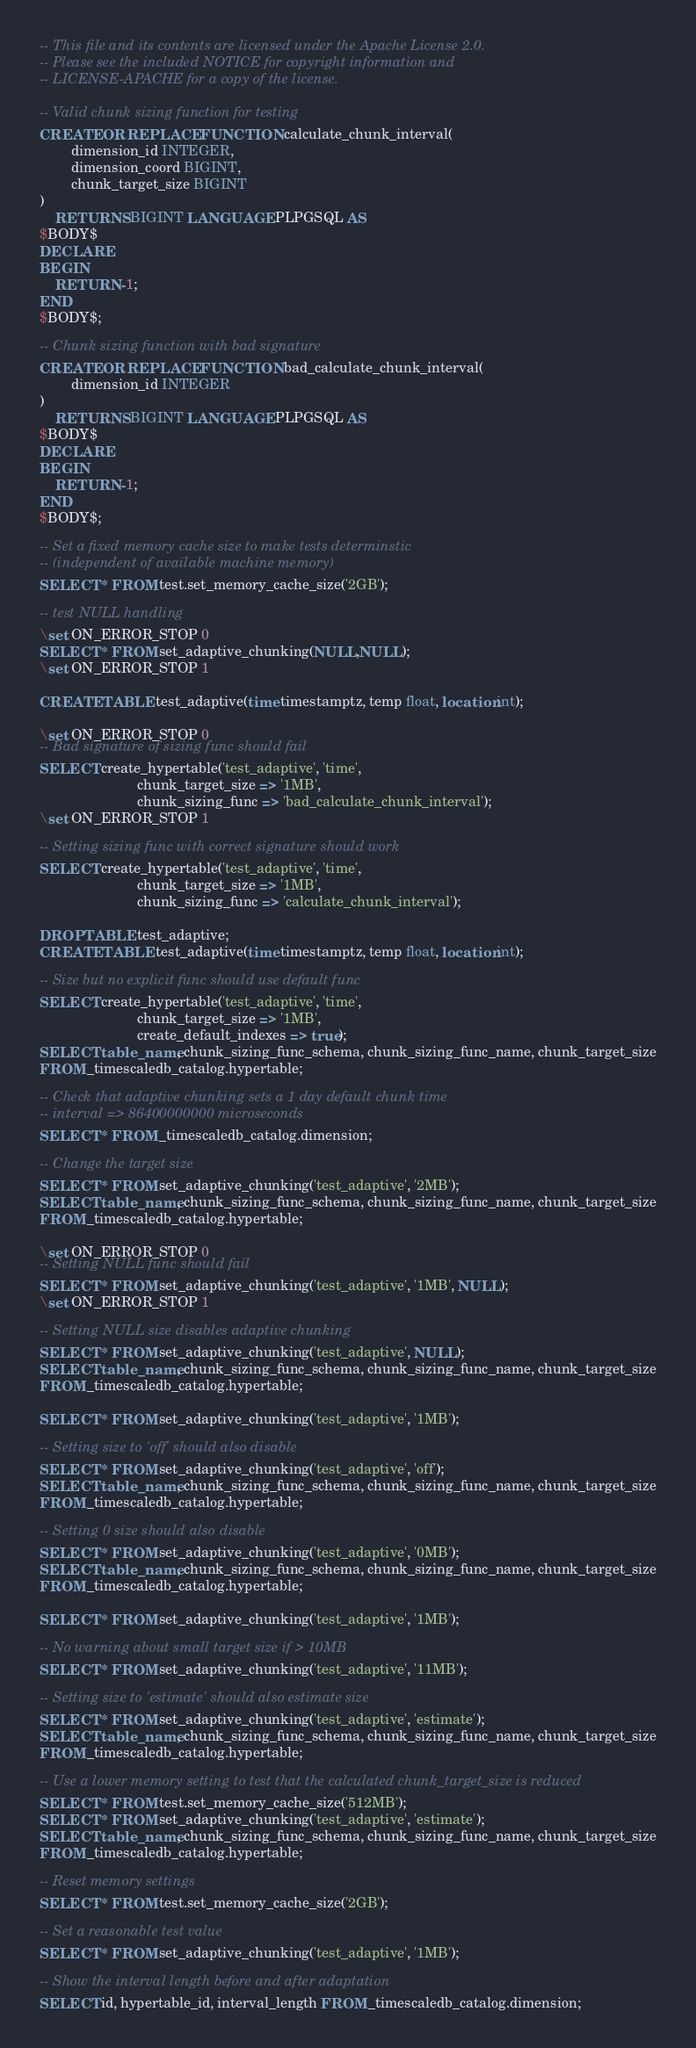<code> <loc_0><loc_0><loc_500><loc_500><_SQL_>-- This file and its contents are licensed under the Apache License 2.0.
-- Please see the included NOTICE for copyright information and
-- LICENSE-APACHE for a copy of the license.

-- Valid chunk sizing function for testing
CREATE OR REPLACE FUNCTION calculate_chunk_interval(
        dimension_id INTEGER,
        dimension_coord BIGINT,
        chunk_target_size BIGINT
)
    RETURNS BIGINT LANGUAGE PLPGSQL AS
$BODY$
DECLARE
BEGIN
    RETURN -1;
END
$BODY$;

-- Chunk sizing function with bad signature
CREATE OR REPLACE FUNCTION bad_calculate_chunk_interval(
        dimension_id INTEGER
)
    RETURNS BIGINT LANGUAGE PLPGSQL AS
$BODY$
DECLARE
BEGIN
    RETURN -1;
END
$BODY$;

-- Set a fixed memory cache size to make tests determinstic
-- (independent of available machine memory)
SELECT * FROM test.set_memory_cache_size('2GB');

-- test NULL handling
\set ON_ERROR_STOP 0
SELECT * FROM set_adaptive_chunking(NULL,NULL);
\set ON_ERROR_STOP 1

CREATE TABLE test_adaptive(time timestamptz, temp float, location int);

\set ON_ERROR_STOP 0
-- Bad signature of sizing func should fail
SELECT create_hypertable('test_adaptive', 'time',
                         chunk_target_size => '1MB',
                         chunk_sizing_func => 'bad_calculate_chunk_interval');
\set ON_ERROR_STOP 1

-- Setting sizing func with correct signature should work
SELECT create_hypertable('test_adaptive', 'time',
                         chunk_target_size => '1MB',
                         chunk_sizing_func => 'calculate_chunk_interval');

DROP TABLE test_adaptive;
CREATE TABLE test_adaptive(time timestamptz, temp float, location int);

-- Size but no explicit func should use default func
SELECT create_hypertable('test_adaptive', 'time',
                         chunk_target_size => '1MB',
                         create_default_indexes => true);
SELECT table_name, chunk_sizing_func_schema, chunk_sizing_func_name, chunk_target_size
FROM _timescaledb_catalog.hypertable;

-- Check that adaptive chunking sets a 1 day default chunk time
-- interval => 86400000000 microseconds
SELECT * FROM _timescaledb_catalog.dimension;

-- Change the target size
SELECT * FROM set_adaptive_chunking('test_adaptive', '2MB');
SELECT table_name, chunk_sizing_func_schema, chunk_sizing_func_name, chunk_target_size
FROM _timescaledb_catalog.hypertable;

\set ON_ERROR_STOP 0
-- Setting NULL func should fail
SELECT * FROM set_adaptive_chunking('test_adaptive', '1MB', NULL);
\set ON_ERROR_STOP 1

-- Setting NULL size disables adaptive chunking
SELECT * FROM set_adaptive_chunking('test_adaptive', NULL);
SELECT table_name, chunk_sizing_func_schema, chunk_sizing_func_name, chunk_target_size
FROM _timescaledb_catalog.hypertable;

SELECT * FROM set_adaptive_chunking('test_adaptive', '1MB');

-- Setting size to 'off' should also disable
SELECT * FROM set_adaptive_chunking('test_adaptive', 'off');
SELECT table_name, chunk_sizing_func_schema, chunk_sizing_func_name, chunk_target_size
FROM _timescaledb_catalog.hypertable;

-- Setting 0 size should also disable
SELECT * FROM set_adaptive_chunking('test_adaptive', '0MB');
SELECT table_name, chunk_sizing_func_schema, chunk_sizing_func_name, chunk_target_size
FROM _timescaledb_catalog.hypertable;

SELECT * FROM set_adaptive_chunking('test_adaptive', '1MB');

-- No warning about small target size if > 10MB
SELECT * FROM set_adaptive_chunking('test_adaptive', '11MB');

-- Setting size to 'estimate' should also estimate size
SELECT * FROM set_adaptive_chunking('test_adaptive', 'estimate');
SELECT table_name, chunk_sizing_func_schema, chunk_sizing_func_name, chunk_target_size
FROM _timescaledb_catalog.hypertable;

-- Use a lower memory setting to test that the calculated chunk_target_size is reduced
SELECT * FROM test.set_memory_cache_size('512MB');
SELECT * FROM set_adaptive_chunking('test_adaptive', 'estimate');
SELECT table_name, chunk_sizing_func_schema, chunk_sizing_func_name, chunk_target_size
FROM _timescaledb_catalog.hypertable;

-- Reset memory settings
SELECT * FROM test.set_memory_cache_size('2GB');

-- Set a reasonable test value
SELECT * FROM set_adaptive_chunking('test_adaptive', '1MB');

-- Show the interval length before and after adaptation
SELECT id, hypertable_id, interval_length FROM _timescaledb_catalog.dimension;
</code> 